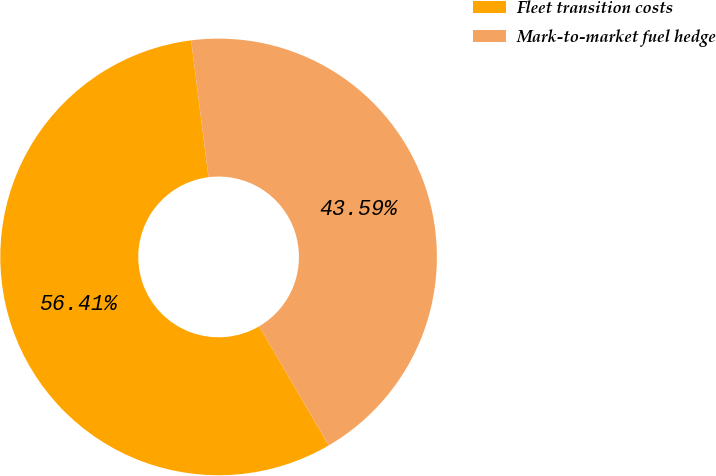Convert chart to OTSL. <chart><loc_0><loc_0><loc_500><loc_500><pie_chart><fcel>Fleet transition costs<fcel>Mark-to-market fuel hedge<nl><fcel>56.41%<fcel>43.59%<nl></chart> 